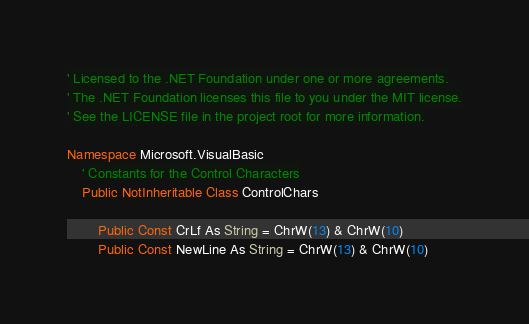<code> <loc_0><loc_0><loc_500><loc_500><_VisualBasic_>' Licensed to the .NET Foundation under one or more agreements.
' The .NET Foundation licenses this file to you under the MIT license.
' See the LICENSE file in the project root for more information.

Namespace Microsoft.VisualBasic
    ' Constants for the Control Characters
    Public NotInheritable Class ControlChars

        Public Const CrLf As String = ChrW(13) & ChrW(10)
        Public Const NewLine As String = ChrW(13) & ChrW(10)</code> 